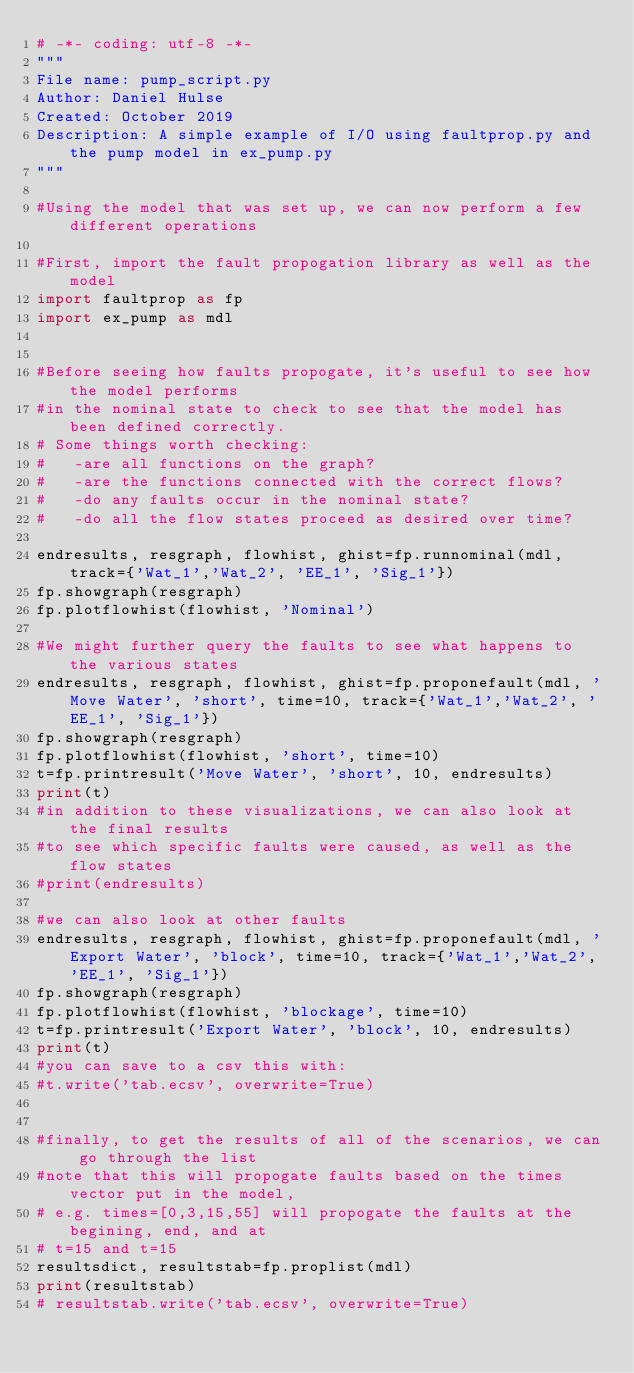Convert code to text. <code><loc_0><loc_0><loc_500><loc_500><_Python_># -*- coding: utf-8 -*-
"""
File name: pump_script.py
Author: Daniel Hulse
Created: October 2019
Description: A simple example of I/O using faultprop.py and the pump model in ex_pump.py
"""

#Using the model that was set up, we can now perform a few different operations

#First, import the fault propogation library as well as the model
import faultprop as fp
import ex_pump as mdl


#Before seeing how faults propogate, it's useful to see how the model performs
#in the nominal state to check to see that the model has been defined correctly.
# Some things worth checking:
#   -are all functions on the graph?
#   -are the functions connected with the correct flows?
#   -do any faults occur in the nominal state?
#   -do all the flow states proceed as desired over time?

endresults, resgraph, flowhist, ghist=fp.runnominal(mdl, track={'Wat_1','Wat_2', 'EE_1', 'Sig_1'})
fp.showgraph(resgraph)
fp.plotflowhist(flowhist, 'Nominal')

#We might further query the faults to see what happens to the various states
endresults, resgraph, flowhist, ghist=fp.proponefault(mdl, 'Move Water', 'short', time=10, track={'Wat_1','Wat_2', 'EE_1', 'Sig_1'})
fp.showgraph(resgraph)
fp.plotflowhist(flowhist, 'short', time=10)
t=fp.printresult('Move Water', 'short', 10, endresults)
print(t)
#in addition to these visualizations, we can also look at the final results 
#to see which specific faults were caused, as well as the flow states
#print(endresults)

#we can also look at other faults
endresults, resgraph, flowhist, ghist=fp.proponefault(mdl, 'Export Water', 'block', time=10, track={'Wat_1','Wat_2', 'EE_1', 'Sig_1'})
fp.showgraph(resgraph)
fp.plotflowhist(flowhist, 'blockage', time=10)
t=fp.printresult('Export Water', 'block', 10, endresults)
print(t)
#you can save to a csv this with:
#t.write('tab.ecsv', overwrite=True)


#finally, to get the results of all of the scenarios, we can go through the list
#note that this will propogate faults based on the times vector put in the model,
# e.g. times=[0,3,15,55] will propogate the faults at the begining, end, and at
# t=15 and t=15
resultsdict, resultstab=fp.proplist(mdl)
print(resultstab)
# resultstab.write('tab.ecsv', overwrite=True)</code> 